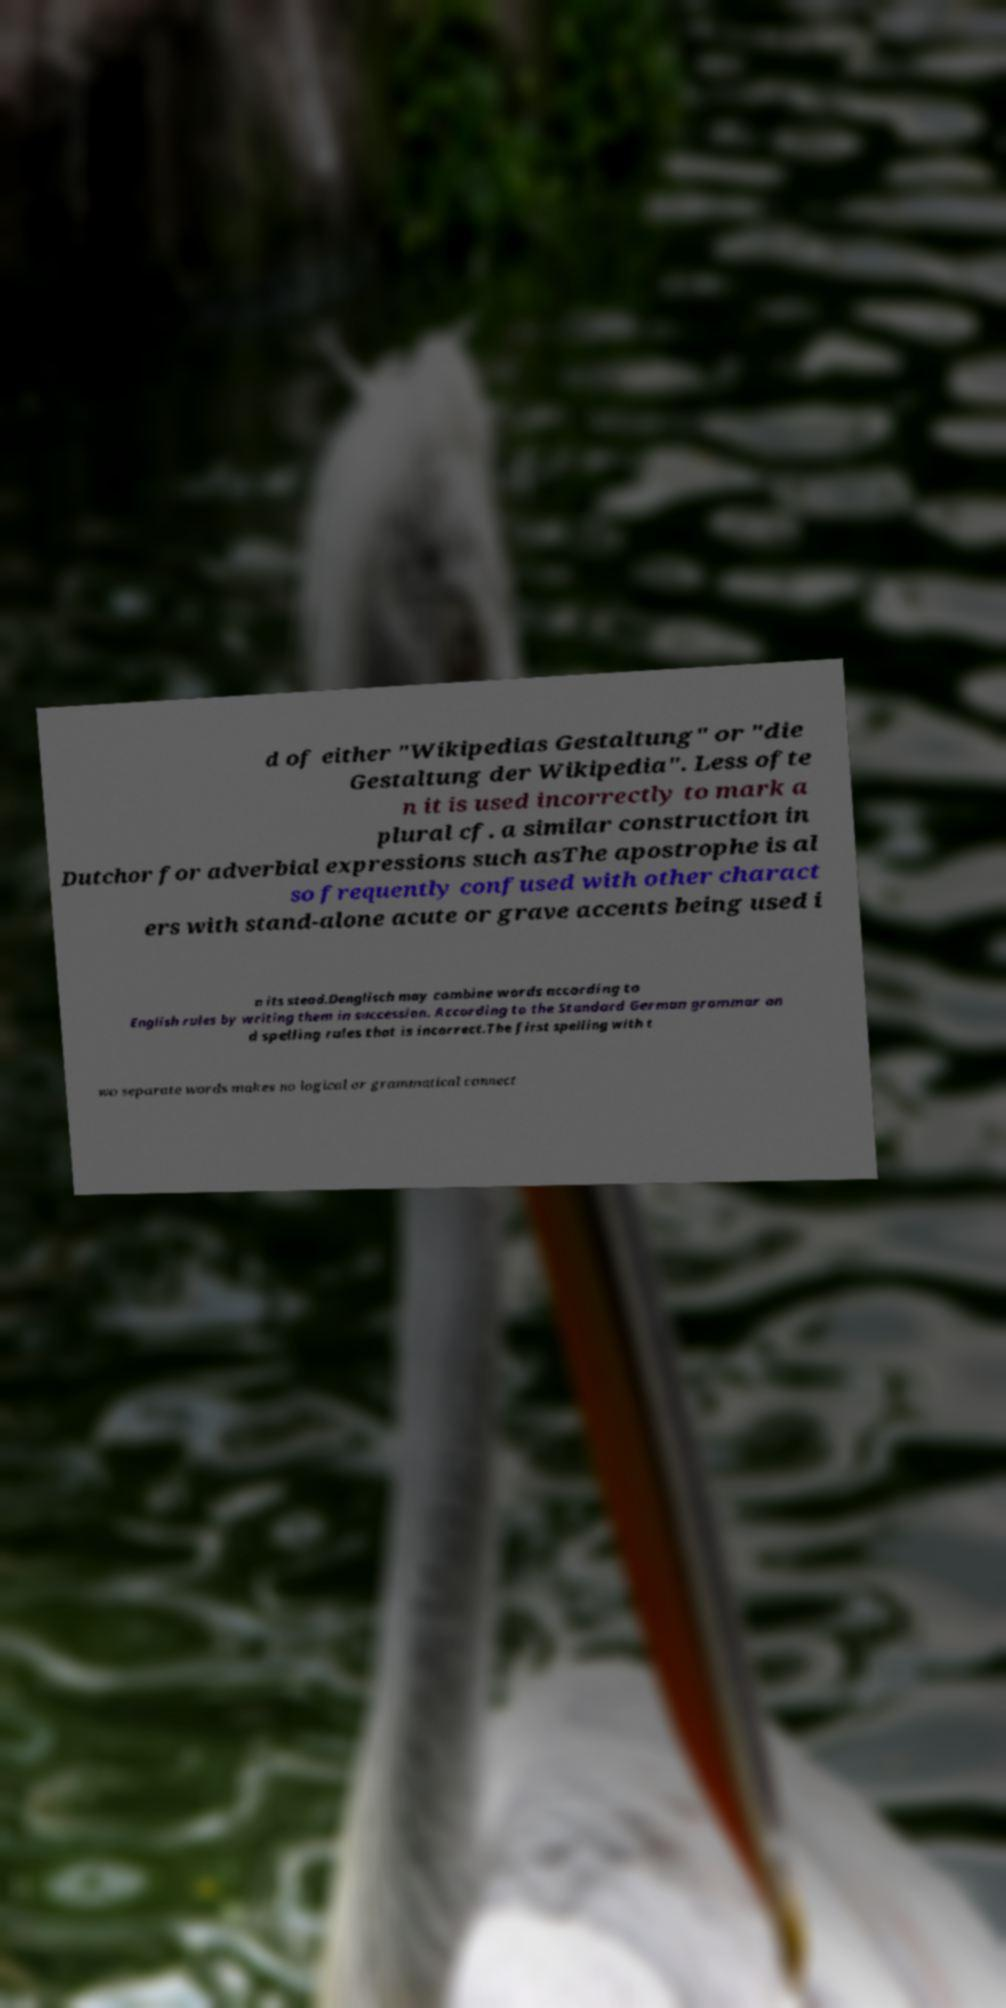Could you extract and type out the text from this image? d of either "Wikipedias Gestaltung" or "die Gestaltung der Wikipedia". Less ofte n it is used incorrectly to mark a plural cf. a similar construction in Dutchor for adverbial expressions such asThe apostrophe is al so frequently confused with other charact ers with stand-alone acute or grave accents being used i n its stead.Denglisch may combine words according to English rules by writing them in succession. According to the Standard German grammar an d spelling rules that is incorrect.The first spelling with t wo separate words makes no logical or grammatical connect 